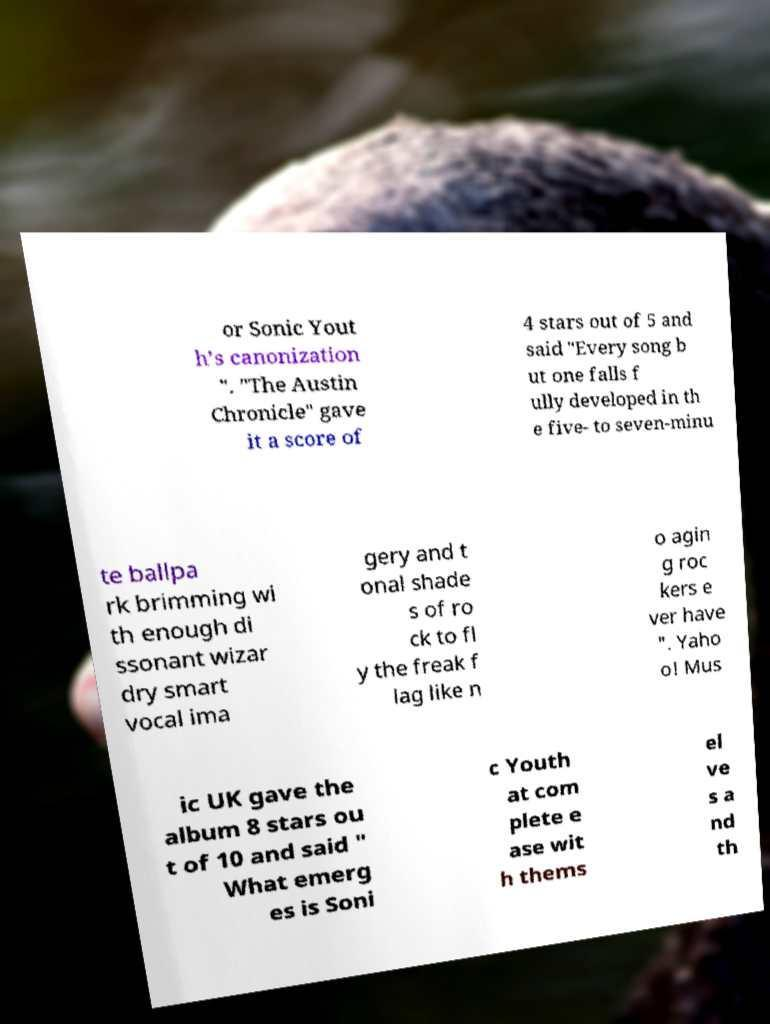Could you extract and type out the text from this image? or Sonic Yout h's canonization ". "The Austin Chronicle" gave it a score of 4 stars out of 5 and said "Every song b ut one falls f ully developed in th e five- to seven-minu te ballpa rk brimming wi th enough di ssonant wizar dry smart vocal ima gery and t onal shade s of ro ck to fl y the freak f lag like n o agin g roc kers e ver have ". Yaho o! Mus ic UK gave the album 8 stars ou t of 10 and said " What emerg es is Soni c Youth at com plete e ase wit h thems el ve s a nd th 